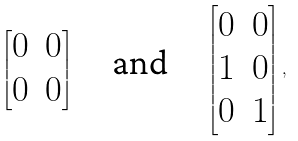Convert formula to latex. <formula><loc_0><loc_0><loc_500><loc_500>\begin{bmatrix} 0 & 0 \\ 0 & 0 \end{bmatrix} \quad \text {and} \quad \begin{bmatrix} 0 & 0 \\ 1 & 0 \\ 0 & 1 \end{bmatrix} ,</formula> 